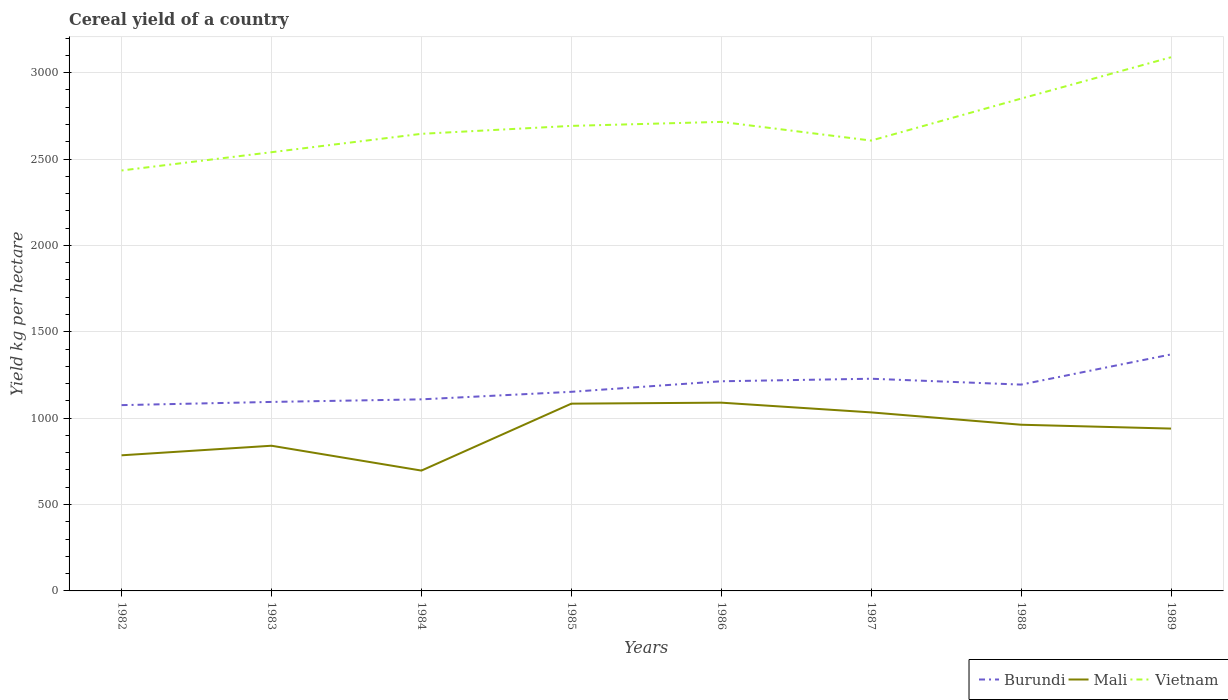Across all years, what is the maximum total cereal yield in Mali?
Your answer should be very brief. 696.56. In which year was the total cereal yield in Burundi maximum?
Provide a short and direct response. 1982. What is the total total cereal yield in Mali in the graph?
Make the answer very short. -154.73. What is the difference between the highest and the second highest total cereal yield in Mali?
Your answer should be compact. 393.21. Is the total cereal yield in Mali strictly greater than the total cereal yield in Vietnam over the years?
Make the answer very short. Yes. Are the values on the major ticks of Y-axis written in scientific E-notation?
Offer a terse response. No. Does the graph contain any zero values?
Your answer should be compact. No. Does the graph contain grids?
Provide a succinct answer. Yes. How are the legend labels stacked?
Offer a terse response. Horizontal. What is the title of the graph?
Offer a terse response. Cereal yield of a country. Does "Gambia, The" appear as one of the legend labels in the graph?
Make the answer very short. No. What is the label or title of the X-axis?
Make the answer very short. Years. What is the label or title of the Y-axis?
Provide a succinct answer. Yield kg per hectare. What is the Yield kg per hectare in Burundi in 1982?
Your answer should be compact. 1075.43. What is the Yield kg per hectare of Mali in 1982?
Offer a terse response. 785. What is the Yield kg per hectare in Vietnam in 1982?
Keep it short and to the point. 2433.62. What is the Yield kg per hectare of Burundi in 1983?
Offer a terse response. 1093.98. What is the Yield kg per hectare in Mali in 1983?
Your answer should be very brief. 840.42. What is the Yield kg per hectare in Vietnam in 1983?
Make the answer very short. 2539.45. What is the Yield kg per hectare in Burundi in 1984?
Make the answer very short. 1108.91. What is the Yield kg per hectare in Mali in 1984?
Your answer should be very brief. 696.56. What is the Yield kg per hectare of Vietnam in 1984?
Ensure brevity in your answer.  2645.85. What is the Yield kg per hectare in Burundi in 1985?
Ensure brevity in your answer.  1152.5. What is the Yield kg per hectare of Mali in 1985?
Your answer should be very brief. 1083.96. What is the Yield kg per hectare of Vietnam in 1985?
Make the answer very short. 2691.79. What is the Yield kg per hectare of Burundi in 1986?
Provide a succinct answer. 1213.53. What is the Yield kg per hectare in Mali in 1986?
Keep it short and to the point. 1089.77. What is the Yield kg per hectare in Vietnam in 1986?
Your response must be concise. 2715.06. What is the Yield kg per hectare of Burundi in 1987?
Make the answer very short. 1228.23. What is the Yield kg per hectare of Mali in 1987?
Offer a terse response. 1033.4. What is the Yield kg per hectare of Vietnam in 1987?
Provide a succinct answer. 2606.82. What is the Yield kg per hectare of Burundi in 1988?
Make the answer very short. 1194.27. What is the Yield kg per hectare of Mali in 1988?
Your answer should be compact. 961.96. What is the Yield kg per hectare of Vietnam in 1988?
Give a very brief answer. 2849.78. What is the Yield kg per hectare of Burundi in 1989?
Your answer should be compact. 1368.96. What is the Yield kg per hectare in Mali in 1989?
Give a very brief answer. 939.73. What is the Yield kg per hectare of Vietnam in 1989?
Give a very brief answer. 3089.15. Across all years, what is the maximum Yield kg per hectare of Burundi?
Your answer should be compact. 1368.96. Across all years, what is the maximum Yield kg per hectare in Mali?
Offer a terse response. 1089.77. Across all years, what is the maximum Yield kg per hectare of Vietnam?
Give a very brief answer. 3089.15. Across all years, what is the minimum Yield kg per hectare of Burundi?
Make the answer very short. 1075.43. Across all years, what is the minimum Yield kg per hectare in Mali?
Provide a short and direct response. 696.56. Across all years, what is the minimum Yield kg per hectare of Vietnam?
Make the answer very short. 2433.62. What is the total Yield kg per hectare of Burundi in the graph?
Your answer should be very brief. 9435.8. What is the total Yield kg per hectare of Mali in the graph?
Make the answer very short. 7430.8. What is the total Yield kg per hectare of Vietnam in the graph?
Your response must be concise. 2.16e+04. What is the difference between the Yield kg per hectare of Burundi in 1982 and that in 1983?
Your response must be concise. -18.55. What is the difference between the Yield kg per hectare of Mali in 1982 and that in 1983?
Give a very brief answer. -55.42. What is the difference between the Yield kg per hectare of Vietnam in 1982 and that in 1983?
Offer a very short reply. -105.83. What is the difference between the Yield kg per hectare in Burundi in 1982 and that in 1984?
Provide a short and direct response. -33.48. What is the difference between the Yield kg per hectare of Mali in 1982 and that in 1984?
Give a very brief answer. 88.44. What is the difference between the Yield kg per hectare of Vietnam in 1982 and that in 1984?
Ensure brevity in your answer.  -212.22. What is the difference between the Yield kg per hectare of Burundi in 1982 and that in 1985?
Provide a short and direct response. -77.07. What is the difference between the Yield kg per hectare in Mali in 1982 and that in 1985?
Your answer should be compact. -298.96. What is the difference between the Yield kg per hectare in Vietnam in 1982 and that in 1985?
Offer a terse response. -258.17. What is the difference between the Yield kg per hectare in Burundi in 1982 and that in 1986?
Offer a very short reply. -138.1. What is the difference between the Yield kg per hectare of Mali in 1982 and that in 1986?
Offer a terse response. -304.77. What is the difference between the Yield kg per hectare in Vietnam in 1982 and that in 1986?
Ensure brevity in your answer.  -281.43. What is the difference between the Yield kg per hectare in Burundi in 1982 and that in 1987?
Ensure brevity in your answer.  -152.81. What is the difference between the Yield kg per hectare of Mali in 1982 and that in 1987?
Ensure brevity in your answer.  -248.4. What is the difference between the Yield kg per hectare in Vietnam in 1982 and that in 1987?
Your answer should be very brief. -173.2. What is the difference between the Yield kg per hectare of Burundi in 1982 and that in 1988?
Offer a very short reply. -118.84. What is the difference between the Yield kg per hectare in Mali in 1982 and that in 1988?
Ensure brevity in your answer.  -176.96. What is the difference between the Yield kg per hectare of Vietnam in 1982 and that in 1988?
Offer a very short reply. -416.16. What is the difference between the Yield kg per hectare of Burundi in 1982 and that in 1989?
Offer a terse response. -293.53. What is the difference between the Yield kg per hectare of Mali in 1982 and that in 1989?
Your response must be concise. -154.73. What is the difference between the Yield kg per hectare of Vietnam in 1982 and that in 1989?
Offer a terse response. -655.53. What is the difference between the Yield kg per hectare in Burundi in 1983 and that in 1984?
Provide a short and direct response. -14.94. What is the difference between the Yield kg per hectare of Mali in 1983 and that in 1984?
Provide a short and direct response. 143.86. What is the difference between the Yield kg per hectare in Vietnam in 1983 and that in 1984?
Your answer should be very brief. -106.4. What is the difference between the Yield kg per hectare of Burundi in 1983 and that in 1985?
Keep it short and to the point. -58.52. What is the difference between the Yield kg per hectare in Mali in 1983 and that in 1985?
Give a very brief answer. -243.54. What is the difference between the Yield kg per hectare of Vietnam in 1983 and that in 1985?
Your answer should be compact. -152.34. What is the difference between the Yield kg per hectare of Burundi in 1983 and that in 1986?
Your answer should be very brief. -119.56. What is the difference between the Yield kg per hectare of Mali in 1983 and that in 1986?
Offer a terse response. -249.35. What is the difference between the Yield kg per hectare of Vietnam in 1983 and that in 1986?
Your answer should be very brief. -175.61. What is the difference between the Yield kg per hectare of Burundi in 1983 and that in 1987?
Your answer should be compact. -134.26. What is the difference between the Yield kg per hectare in Mali in 1983 and that in 1987?
Give a very brief answer. -192.98. What is the difference between the Yield kg per hectare in Vietnam in 1983 and that in 1987?
Your answer should be compact. -67.37. What is the difference between the Yield kg per hectare of Burundi in 1983 and that in 1988?
Keep it short and to the point. -100.29. What is the difference between the Yield kg per hectare of Mali in 1983 and that in 1988?
Keep it short and to the point. -121.54. What is the difference between the Yield kg per hectare in Vietnam in 1983 and that in 1988?
Ensure brevity in your answer.  -310.33. What is the difference between the Yield kg per hectare in Burundi in 1983 and that in 1989?
Your response must be concise. -274.98. What is the difference between the Yield kg per hectare of Mali in 1983 and that in 1989?
Give a very brief answer. -99.31. What is the difference between the Yield kg per hectare of Vietnam in 1983 and that in 1989?
Make the answer very short. -549.7. What is the difference between the Yield kg per hectare of Burundi in 1984 and that in 1985?
Offer a very short reply. -43.59. What is the difference between the Yield kg per hectare of Mali in 1984 and that in 1985?
Your answer should be very brief. -387.39. What is the difference between the Yield kg per hectare in Vietnam in 1984 and that in 1985?
Give a very brief answer. -45.94. What is the difference between the Yield kg per hectare of Burundi in 1984 and that in 1986?
Your answer should be very brief. -104.62. What is the difference between the Yield kg per hectare of Mali in 1984 and that in 1986?
Ensure brevity in your answer.  -393.21. What is the difference between the Yield kg per hectare of Vietnam in 1984 and that in 1986?
Your answer should be very brief. -69.21. What is the difference between the Yield kg per hectare in Burundi in 1984 and that in 1987?
Make the answer very short. -119.32. What is the difference between the Yield kg per hectare in Mali in 1984 and that in 1987?
Provide a succinct answer. -336.84. What is the difference between the Yield kg per hectare in Vietnam in 1984 and that in 1987?
Keep it short and to the point. 39.03. What is the difference between the Yield kg per hectare in Burundi in 1984 and that in 1988?
Offer a terse response. -85.36. What is the difference between the Yield kg per hectare in Mali in 1984 and that in 1988?
Your answer should be compact. -265.4. What is the difference between the Yield kg per hectare of Vietnam in 1984 and that in 1988?
Your response must be concise. -203.94. What is the difference between the Yield kg per hectare of Burundi in 1984 and that in 1989?
Your answer should be very brief. -260.05. What is the difference between the Yield kg per hectare of Mali in 1984 and that in 1989?
Provide a short and direct response. -243.16. What is the difference between the Yield kg per hectare of Vietnam in 1984 and that in 1989?
Ensure brevity in your answer.  -443.3. What is the difference between the Yield kg per hectare of Burundi in 1985 and that in 1986?
Your answer should be compact. -61.03. What is the difference between the Yield kg per hectare of Mali in 1985 and that in 1986?
Offer a terse response. -5.82. What is the difference between the Yield kg per hectare in Vietnam in 1985 and that in 1986?
Ensure brevity in your answer.  -23.27. What is the difference between the Yield kg per hectare of Burundi in 1985 and that in 1987?
Provide a short and direct response. -75.73. What is the difference between the Yield kg per hectare of Mali in 1985 and that in 1987?
Keep it short and to the point. 50.55. What is the difference between the Yield kg per hectare of Vietnam in 1985 and that in 1987?
Ensure brevity in your answer.  84.97. What is the difference between the Yield kg per hectare of Burundi in 1985 and that in 1988?
Offer a very short reply. -41.77. What is the difference between the Yield kg per hectare of Mali in 1985 and that in 1988?
Your response must be concise. 122. What is the difference between the Yield kg per hectare in Vietnam in 1985 and that in 1988?
Ensure brevity in your answer.  -158. What is the difference between the Yield kg per hectare of Burundi in 1985 and that in 1989?
Provide a succinct answer. -216.46. What is the difference between the Yield kg per hectare in Mali in 1985 and that in 1989?
Offer a terse response. 144.23. What is the difference between the Yield kg per hectare in Vietnam in 1985 and that in 1989?
Your answer should be compact. -397.36. What is the difference between the Yield kg per hectare in Burundi in 1986 and that in 1987?
Ensure brevity in your answer.  -14.7. What is the difference between the Yield kg per hectare of Mali in 1986 and that in 1987?
Provide a short and direct response. 56.37. What is the difference between the Yield kg per hectare in Vietnam in 1986 and that in 1987?
Provide a succinct answer. 108.24. What is the difference between the Yield kg per hectare in Burundi in 1986 and that in 1988?
Offer a very short reply. 19.26. What is the difference between the Yield kg per hectare in Mali in 1986 and that in 1988?
Provide a succinct answer. 127.81. What is the difference between the Yield kg per hectare in Vietnam in 1986 and that in 1988?
Give a very brief answer. -134.73. What is the difference between the Yield kg per hectare in Burundi in 1986 and that in 1989?
Provide a short and direct response. -155.43. What is the difference between the Yield kg per hectare of Mali in 1986 and that in 1989?
Your response must be concise. 150.05. What is the difference between the Yield kg per hectare in Vietnam in 1986 and that in 1989?
Make the answer very short. -374.1. What is the difference between the Yield kg per hectare in Burundi in 1987 and that in 1988?
Your answer should be very brief. 33.96. What is the difference between the Yield kg per hectare of Mali in 1987 and that in 1988?
Make the answer very short. 71.44. What is the difference between the Yield kg per hectare in Vietnam in 1987 and that in 1988?
Your answer should be compact. -242.96. What is the difference between the Yield kg per hectare of Burundi in 1987 and that in 1989?
Your answer should be compact. -140.72. What is the difference between the Yield kg per hectare of Mali in 1987 and that in 1989?
Provide a short and direct response. 93.68. What is the difference between the Yield kg per hectare in Vietnam in 1987 and that in 1989?
Offer a very short reply. -482.33. What is the difference between the Yield kg per hectare of Burundi in 1988 and that in 1989?
Your answer should be compact. -174.69. What is the difference between the Yield kg per hectare of Mali in 1988 and that in 1989?
Offer a very short reply. 22.23. What is the difference between the Yield kg per hectare in Vietnam in 1988 and that in 1989?
Offer a very short reply. -239.37. What is the difference between the Yield kg per hectare of Burundi in 1982 and the Yield kg per hectare of Mali in 1983?
Make the answer very short. 235. What is the difference between the Yield kg per hectare of Burundi in 1982 and the Yield kg per hectare of Vietnam in 1983?
Offer a terse response. -1464.02. What is the difference between the Yield kg per hectare in Mali in 1982 and the Yield kg per hectare in Vietnam in 1983?
Ensure brevity in your answer.  -1754.45. What is the difference between the Yield kg per hectare in Burundi in 1982 and the Yield kg per hectare in Mali in 1984?
Your answer should be very brief. 378.86. What is the difference between the Yield kg per hectare of Burundi in 1982 and the Yield kg per hectare of Vietnam in 1984?
Ensure brevity in your answer.  -1570.42. What is the difference between the Yield kg per hectare in Mali in 1982 and the Yield kg per hectare in Vietnam in 1984?
Keep it short and to the point. -1860.85. What is the difference between the Yield kg per hectare in Burundi in 1982 and the Yield kg per hectare in Mali in 1985?
Provide a short and direct response. -8.53. What is the difference between the Yield kg per hectare of Burundi in 1982 and the Yield kg per hectare of Vietnam in 1985?
Ensure brevity in your answer.  -1616.36. What is the difference between the Yield kg per hectare of Mali in 1982 and the Yield kg per hectare of Vietnam in 1985?
Offer a very short reply. -1906.79. What is the difference between the Yield kg per hectare in Burundi in 1982 and the Yield kg per hectare in Mali in 1986?
Ensure brevity in your answer.  -14.35. What is the difference between the Yield kg per hectare in Burundi in 1982 and the Yield kg per hectare in Vietnam in 1986?
Give a very brief answer. -1639.63. What is the difference between the Yield kg per hectare in Mali in 1982 and the Yield kg per hectare in Vietnam in 1986?
Your response must be concise. -1930.06. What is the difference between the Yield kg per hectare in Burundi in 1982 and the Yield kg per hectare in Mali in 1987?
Your answer should be very brief. 42.02. What is the difference between the Yield kg per hectare in Burundi in 1982 and the Yield kg per hectare in Vietnam in 1987?
Provide a succinct answer. -1531.39. What is the difference between the Yield kg per hectare of Mali in 1982 and the Yield kg per hectare of Vietnam in 1987?
Provide a succinct answer. -1821.82. What is the difference between the Yield kg per hectare of Burundi in 1982 and the Yield kg per hectare of Mali in 1988?
Your response must be concise. 113.47. What is the difference between the Yield kg per hectare of Burundi in 1982 and the Yield kg per hectare of Vietnam in 1988?
Offer a terse response. -1774.36. What is the difference between the Yield kg per hectare in Mali in 1982 and the Yield kg per hectare in Vietnam in 1988?
Your answer should be compact. -2064.78. What is the difference between the Yield kg per hectare of Burundi in 1982 and the Yield kg per hectare of Mali in 1989?
Offer a terse response. 135.7. What is the difference between the Yield kg per hectare of Burundi in 1982 and the Yield kg per hectare of Vietnam in 1989?
Your response must be concise. -2013.72. What is the difference between the Yield kg per hectare in Mali in 1982 and the Yield kg per hectare in Vietnam in 1989?
Ensure brevity in your answer.  -2304.15. What is the difference between the Yield kg per hectare in Burundi in 1983 and the Yield kg per hectare in Mali in 1984?
Offer a very short reply. 397.41. What is the difference between the Yield kg per hectare of Burundi in 1983 and the Yield kg per hectare of Vietnam in 1984?
Keep it short and to the point. -1551.87. What is the difference between the Yield kg per hectare of Mali in 1983 and the Yield kg per hectare of Vietnam in 1984?
Your response must be concise. -1805.43. What is the difference between the Yield kg per hectare in Burundi in 1983 and the Yield kg per hectare in Mali in 1985?
Provide a succinct answer. 10.02. What is the difference between the Yield kg per hectare of Burundi in 1983 and the Yield kg per hectare of Vietnam in 1985?
Your response must be concise. -1597.81. What is the difference between the Yield kg per hectare in Mali in 1983 and the Yield kg per hectare in Vietnam in 1985?
Give a very brief answer. -1851.37. What is the difference between the Yield kg per hectare of Burundi in 1983 and the Yield kg per hectare of Mali in 1986?
Provide a succinct answer. 4.2. What is the difference between the Yield kg per hectare in Burundi in 1983 and the Yield kg per hectare in Vietnam in 1986?
Keep it short and to the point. -1621.08. What is the difference between the Yield kg per hectare of Mali in 1983 and the Yield kg per hectare of Vietnam in 1986?
Your answer should be very brief. -1874.63. What is the difference between the Yield kg per hectare in Burundi in 1983 and the Yield kg per hectare in Mali in 1987?
Your answer should be compact. 60.57. What is the difference between the Yield kg per hectare in Burundi in 1983 and the Yield kg per hectare in Vietnam in 1987?
Ensure brevity in your answer.  -1512.84. What is the difference between the Yield kg per hectare of Mali in 1983 and the Yield kg per hectare of Vietnam in 1987?
Provide a succinct answer. -1766.4. What is the difference between the Yield kg per hectare of Burundi in 1983 and the Yield kg per hectare of Mali in 1988?
Provide a short and direct response. 132.02. What is the difference between the Yield kg per hectare in Burundi in 1983 and the Yield kg per hectare in Vietnam in 1988?
Your response must be concise. -1755.81. What is the difference between the Yield kg per hectare in Mali in 1983 and the Yield kg per hectare in Vietnam in 1988?
Give a very brief answer. -2009.36. What is the difference between the Yield kg per hectare in Burundi in 1983 and the Yield kg per hectare in Mali in 1989?
Your answer should be compact. 154.25. What is the difference between the Yield kg per hectare in Burundi in 1983 and the Yield kg per hectare in Vietnam in 1989?
Give a very brief answer. -1995.17. What is the difference between the Yield kg per hectare in Mali in 1983 and the Yield kg per hectare in Vietnam in 1989?
Offer a terse response. -2248.73. What is the difference between the Yield kg per hectare in Burundi in 1984 and the Yield kg per hectare in Mali in 1985?
Provide a short and direct response. 24.95. What is the difference between the Yield kg per hectare of Burundi in 1984 and the Yield kg per hectare of Vietnam in 1985?
Your response must be concise. -1582.88. What is the difference between the Yield kg per hectare of Mali in 1984 and the Yield kg per hectare of Vietnam in 1985?
Provide a succinct answer. -1995.23. What is the difference between the Yield kg per hectare in Burundi in 1984 and the Yield kg per hectare in Mali in 1986?
Offer a very short reply. 19.14. What is the difference between the Yield kg per hectare of Burundi in 1984 and the Yield kg per hectare of Vietnam in 1986?
Your response must be concise. -1606.14. What is the difference between the Yield kg per hectare of Mali in 1984 and the Yield kg per hectare of Vietnam in 1986?
Your response must be concise. -2018.49. What is the difference between the Yield kg per hectare in Burundi in 1984 and the Yield kg per hectare in Mali in 1987?
Give a very brief answer. 75.51. What is the difference between the Yield kg per hectare in Burundi in 1984 and the Yield kg per hectare in Vietnam in 1987?
Offer a very short reply. -1497.91. What is the difference between the Yield kg per hectare of Mali in 1984 and the Yield kg per hectare of Vietnam in 1987?
Your answer should be very brief. -1910.26. What is the difference between the Yield kg per hectare in Burundi in 1984 and the Yield kg per hectare in Mali in 1988?
Keep it short and to the point. 146.95. What is the difference between the Yield kg per hectare of Burundi in 1984 and the Yield kg per hectare of Vietnam in 1988?
Give a very brief answer. -1740.87. What is the difference between the Yield kg per hectare in Mali in 1984 and the Yield kg per hectare in Vietnam in 1988?
Give a very brief answer. -2153.22. What is the difference between the Yield kg per hectare of Burundi in 1984 and the Yield kg per hectare of Mali in 1989?
Your response must be concise. 169.18. What is the difference between the Yield kg per hectare in Burundi in 1984 and the Yield kg per hectare in Vietnam in 1989?
Your answer should be compact. -1980.24. What is the difference between the Yield kg per hectare of Mali in 1984 and the Yield kg per hectare of Vietnam in 1989?
Provide a succinct answer. -2392.59. What is the difference between the Yield kg per hectare of Burundi in 1985 and the Yield kg per hectare of Mali in 1986?
Make the answer very short. 62.73. What is the difference between the Yield kg per hectare of Burundi in 1985 and the Yield kg per hectare of Vietnam in 1986?
Offer a terse response. -1562.56. What is the difference between the Yield kg per hectare in Mali in 1985 and the Yield kg per hectare in Vietnam in 1986?
Keep it short and to the point. -1631.1. What is the difference between the Yield kg per hectare of Burundi in 1985 and the Yield kg per hectare of Mali in 1987?
Give a very brief answer. 119.1. What is the difference between the Yield kg per hectare in Burundi in 1985 and the Yield kg per hectare in Vietnam in 1987?
Ensure brevity in your answer.  -1454.32. What is the difference between the Yield kg per hectare in Mali in 1985 and the Yield kg per hectare in Vietnam in 1987?
Your answer should be compact. -1522.86. What is the difference between the Yield kg per hectare of Burundi in 1985 and the Yield kg per hectare of Mali in 1988?
Provide a short and direct response. 190.54. What is the difference between the Yield kg per hectare in Burundi in 1985 and the Yield kg per hectare in Vietnam in 1988?
Give a very brief answer. -1697.28. What is the difference between the Yield kg per hectare of Mali in 1985 and the Yield kg per hectare of Vietnam in 1988?
Provide a short and direct response. -1765.83. What is the difference between the Yield kg per hectare in Burundi in 1985 and the Yield kg per hectare in Mali in 1989?
Offer a very short reply. 212.77. What is the difference between the Yield kg per hectare of Burundi in 1985 and the Yield kg per hectare of Vietnam in 1989?
Give a very brief answer. -1936.65. What is the difference between the Yield kg per hectare in Mali in 1985 and the Yield kg per hectare in Vietnam in 1989?
Your answer should be compact. -2005.19. What is the difference between the Yield kg per hectare of Burundi in 1986 and the Yield kg per hectare of Mali in 1987?
Provide a short and direct response. 180.13. What is the difference between the Yield kg per hectare in Burundi in 1986 and the Yield kg per hectare in Vietnam in 1987?
Give a very brief answer. -1393.29. What is the difference between the Yield kg per hectare of Mali in 1986 and the Yield kg per hectare of Vietnam in 1987?
Offer a terse response. -1517.05. What is the difference between the Yield kg per hectare of Burundi in 1986 and the Yield kg per hectare of Mali in 1988?
Make the answer very short. 251.57. What is the difference between the Yield kg per hectare of Burundi in 1986 and the Yield kg per hectare of Vietnam in 1988?
Ensure brevity in your answer.  -1636.25. What is the difference between the Yield kg per hectare of Mali in 1986 and the Yield kg per hectare of Vietnam in 1988?
Ensure brevity in your answer.  -1760.01. What is the difference between the Yield kg per hectare of Burundi in 1986 and the Yield kg per hectare of Mali in 1989?
Give a very brief answer. 273.8. What is the difference between the Yield kg per hectare of Burundi in 1986 and the Yield kg per hectare of Vietnam in 1989?
Provide a short and direct response. -1875.62. What is the difference between the Yield kg per hectare in Mali in 1986 and the Yield kg per hectare in Vietnam in 1989?
Ensure brevity in your answer.  -1999.38. What is the difference between the Yield kg per hectare of Burundi in 1987 and the Yield kg per hectare of Mali in 1988?
Provide a short and direct response. 266.27. What is the difference between the Yield kg per hectare of Burundi in 1987 and the Yield kg per hectare of Vietnam in 1988?
Provide a short and direct response. -1621.55. What is the difference between the Yield kg per hectare of Mali in 1987 and the Yield kg per hectare of Vietnam in 1988?
Offer a terse response. -1816.38. What is the difference between the Yield kg per hectare in Burundi in 1987 and the Yield kg per hectare in Mali in 1989?
Make the answer very short. 288.5. What is the difference between the Yield kg per hectare of Burundi in 1987 and the Yield kg per hectare of Vietnam in 1989?
Your answer should be very brief. -1860.92. What is the difference between the Yield kg per hectare in Mali in 1987 and the Yield kg per hectare in Vietnam in 1989?
Your answer should be very brief. -2055.75. What is the difference between the Yield kg per hectare of Burundi in 1988 and the Yield kg per hectare of Mali in 1989?
Offer a very short reply. 254.54. What is the difference between the Yield kg per hectare of Burundi in 1988 and the Yield kg per hectare of Vietnam in 1989?
Ensure brevity in your answer.  -1894.88. What is the difference between the Yield kg per hectare of Mali in 1988 and the Yield kg per hectare of Vietnam in 1989?
Give a very brief answer. -2127.19. What is the average Yield kg per hectare of Burundi per year?
Your answer should be compact. 1179.47. What is the average Yield kg per hectare of Mali per year?
Keep it short and to the point. 928.85. What is the average Yield kg per hectare in Vietnam per year?
Keep it short and to the point. 2696.44. In the year 1982, what is the difference between the Yield kg per hectare in Burundi and Yield kg per hectare in Mali?
Make the answer very short. 290.43. In the year 1982, what is the difference between the Yield kg per hectare of Burundi and Yield kg per hectare of Vietnam?
Give a very brief answer. -1358.2. In the year 1982, what is the difference between the Yield kg per hectare of Mali and Yield kg per hectare of Vietnam?
Your response must be concise. -1648.62. In the year 1983, what is the difference between the Yield kg per hectare in Burundi and Yield kg per hectare in Mali?
Provide a succinct answer. 253.56. In the year 1983, what is the difference between the Yield kg per hectare of Burundi and Yield kg per hectare of Vietnam?
Your answer should be compact. -1445.47. In the year 1983, what is the difference between the Yield kg per hectare of Mali and Yield kg per hectare of Vietnam?
Your answer should be very brief. -1699.03. In the year 1984, what is the difference between the Yield kg per hectare in Burundi and Yield kg per hectare in Mali?
Your response must be concise. 412.35. In the year 1984, what is the difference between the Yield kg per hectare in Burundi and Yield kg per hectare in Vietnam?
Keep it short and to the point. -1536.94. In the year 1984, what is the difference between the Yield kg per hectare in Mali and Yield kg per hectare in Vietnam?
Your answer should be compact. -1949.29. In the year 1985, what is the difference between the Yield kg per hectare in Burundi and Yield kg per hectare in Mali?
Keep it short and to the point. 68.54. In the year 1985, what is the difference between the Yield kg per hectare in Burundi and Yield kg per hectare in Vietnam?
Keep it short and to the point. -1539.29. In the year 1985, what is the difference between the Yield kg per hectare of Mali and Yield kg per hectare of Vietnam?
Make the answer very short. -1607.83. In the year 1986, what is the difference between the Yield kg per hectare of Burundi and Yield kg per hectare of Mali?
Offer a very short reply. 123.76. In the year 1986, what is the difference between the Yield kg per hectare of Burundi and Yield kg per hectare of Vietnam?
Make the answer very short. -1501.53. In the year 1986, what is the difference between the Yield kg per hectare of Mali and Yield kg per hectare of Vietnam?
Provide a succinct answer. -1625.28. In the year 1987, what is the difference between the Yield kg per hectare in Burundi and Yield kg per hectare in Mali?
Your answer should be very brief. 194.83. In the year 1987, what is the difference between the Yield kg per hectare of Burundi and Yield kg per hectare of Vietnam?
Keep it short and to the point. -1378.59. In the year 1987, what is the difference between the Yield kg per hectare of Mali and Yield kg per hectare of Vietnam?
Your answer should be very brief. -1573.42. In the year 1988, what is the difference between the Yield kg per hectare of Burundi and Yield kg per hectare of Mali?
Give a very brief answer. 232.31. In the year 1988, what is the difference between the Yield kg per hectare of Burundi and Yield kg per hectare of Vietnam?
Your answer should be very brief. -1655.52. In the year 1988, what is the difference between the Yield kg per hectare of Mali and Yield kg per hectare of Vietnam?
Make the answer very short. -1887.82. In the year 1989, what is the difference between the Yield kg per hectare in Burundi and Yield kg per hectare in Mali?
Provide a succinct answer. 429.23. In the year 1989, what is the difference between the Yield kg per hectare of Burundi and Yield kg per hectare of Vietnam?
Give a very brief answer. -1720.19. In the year 1989, what is the difference between the Yield kg per hectare of Mali and Yield kg per hectare of Vietnam?
Your response must be concise. -2149.42. What is the ratio of the Yield kg per hectare of Burundi in 1982 to that in 1983?
Provide a short and direct response. 0.98. What is the ratio of the Yield kg per hectare of Mali in 1982 to that in 1983?
Your response must be concise. 0.93. What is the ratio of the Yield kg per hectare of Vietnam in 1982 to that in 1983?
Keep it short and to the point. 0.96. What is the ratio of the Yield kg per hectare in Burundi in 1982 to that in 1984?
Keep it short and to the point. 0.97. What is the ratio of the Yield kg per hectare of Mali in 1982 to that in 1984?
Give a very brief answer. 1.13. What is the ratio of the Yield kg per hectare in Vietnam in 1982 to that in 1984?
Offer a terse response. 0.92. What is the ratio of the Yield kg per hectare of Burundi in 1982 to that in 1985?
Give a very brief answer. 0.93. What is the ratio of the Yield kg per hectare in Mali in 1982 to that in 1985?
Provide a succinct answer. 0.72. What is the ratio of the Yield kg per hectare in Vietnam in 1982 to that in 1985?
Give a very brief answer. 0.9. What is the ratio of the Yield kg per hectare of Burundi in 1982 to that in 1986?
Your answer should be very brief. 0.89. What is the ratio of the Yield kg per hectare of Mali in 1982 to that in 1986?
Give a very brief answer. 0.72. What is the ratio of the Yield kg per hectare in Vietnam in 1982 to that in 1986?
Provide a succinct answer. 0.9. What is the ratio of the Yield kg per hectare in Burundi in 1982 to that in 1987?
Provide a short and direct response. 0.88. What is the ratio of the Yield kg per hectare of Mali in 1982 to that in 1987?
Make the answer very short. 0.76. What is the ratio of the Yield kg per hectare of Vietnam in 1982 to that in 1987?
Offer a terse response. 0.93. What is the ratio of the Yield kg per hectare in Burundi in 1982 to that in 1988?
Provide a short and direct response. 0.9. What is the ratio of the Yield kg per hectare in Mali in 1982 to that in 1988?
Offer a very short reply. 0.82. What is the ratio of the Yield kg per hectare in Vietnam in 1982 to that in 1988?
Your response must be concise. 0.85. What is the ratio of the Yield kg per hectare of Burundi in 1982 to that in 1989?
Your response must be concise. 0.79. What is the ratio of the Yield kg per hectare of Mali in 1982 to that in 1989?
Ensure brevity in your answer.  0.84. What is the ratio of the Yield kg per hectare of Vietnam in 1982 to that in 1989?
Keep it short and to the point. 0.79. What is the ratio of the Yield kg per hectare in Burundi in 1983 to that in 1984?
Give a very brief answer. 0.99. What is the ratio of the Yield kg per hectare of Mali in 1983 to that in 1984?
Your response must be concise. 1.21. What is the ratio of the Yield kg per hectare of Vietnam in 1983 to that in 1984?
Your answer should be very brief. 0.96. What is the ratio of the Yield kg per hectare of Burundi in 1983 to that in 1985?
Give a very brief answer. 0.95. What is the ratio of the Yield kg per hectare of Mali in 1983 to that in 1985?
Your answer should be very brief. 0.78. What is the ratio of the Yield kg per hectare in Vietnam in 1983 to that in 1985?
Keep it short and to the point. 0.94. What is the ratio of the Yield kg per hectare in Burundi in 1983 to that in 1986?
Make the answer very short. 0.9. What is the ratio of the Yield kg per hectare of Mali in 1983 to that in 1986?
Make the answer very short. 0.77. What is the ratio of the Yield kg per hectare in Vietnam in 1983 to that in 1986?
Your answer should be compact. 0.94. What is the ratio of the Yield kg per hectare of Burundi in 1983 to that in 1987?
Keep it short and to the point. 0.89. What is the ratio of the Yield kg per hectare in Mali in 1983 to that in 1987?
Ensure brevity in your answer.  0.81. What is the ratio of the Yield kg per hectare in Vietnam in 1983 to that in 1987?
Give a very brief answer. 0.97. What is the ratio of the Yield kg per hectare in Burundi in 1983 to that in 1988?
Ensure brevity in your answer.  0.92. What is the ratio of the Yield kg per hectare of Mali in 1983 to that in 1988?
Offer a very short reply. 0.87. What is the ratio of the Yield kg per hectare in Vietnam in 1983 to that in 1988?
Make the answer very short. 0.89. What is the ratio of the Yield kg per hectare of Burundi in 1983 to that in 1989?
Give a very brief answer. 0.8. What is the ratio of the Yield kg per hectare in Mali in 1983 to that in 1989?
Provide a short and direct response. 0.89. What is the ratio of the Yield kg per hectare in Vietnam in 1983 to that in 1989?
Give a very brief answer. 0.82. What is the ratio of the Yield kg per hectare in Burundi in 1984 to that in 1985?
Offer a terse response. 0.96. What is the ratio of the Yield kg per hectare of Mali in 1984 to that in 1985?
Offer a very short reply. 0.64. What is the ratio of the Yield kg per hectare of Vietnam in 1984 to that in 1985?
Provide a succinct answer. 0.98. What is the ratio of the Yield kg per hectare of Burundi in 1984 to that in 1986?
Offer a terse response. 0.91. What is the ratio of the Yield kg per hectare of Mali in 1984 to that in 1986?
Your answer should be very brief. 0.64. What is the ratio of the Yield kg per hectare of Vietnam in 1984 to that in 1986?
Provide a succinct answer. 0.97. What is the ratio of the Yield kg per hectare of Burundi in 1984 to that in 1987?
Your response must be concise. 0.9. What is the ratio of the Yield kg per hectare in Mali in 1984 to that in 1987?
Your answer should be very brief. 0.67. What is the ratio of the Yield kg per hectare in Vietnam in 1984 to that in 1987?
Your response must be concise. 1.01. What is the ratio of the Yield kg per hectare of Burundi in 1984 to that in 1988?
Give a very brief answer. 0.93. What is the ratio of the Yield kg per hectare of Mali in 1984 to that in 1988?
Offer a very short reply. 0.72. What is the ratio of the Yield kg per hectare in Vietnam in 1984 to that in 1988?
Your response must be concise. 0.93. What is the ratio of the Yield kg per hectare of Burundi in 1984 to that in 1989?
Provide a succinct answer. 0.81. What is the ratio of the Yield kg per hectare in Mali in 1984 to that in 1989?
Your answer should be compact. 0.74. What is the ratio of the Yield kg per hectare of Vietnam in 1984 to that in 1989?
Keep it short and to the point. 0.86. What is the ratio of the Yield kg per hectare in Burundi in 1985 to that in 1986?
Your response must be concise. 0.95. What is the ratio of the Yield kg per hectare of Vietnam in 1985 to that in 1986?
Ensure brevity in your answer.  0.99. What is the ratio of the Yield kg per hectare of Burundi in 1985 to that in 1987?
Offer a very short reply. 0.94. What is the ratio of the Yield kg per hectare of Mali in 1985 to that in 1987?
Provide a short and direct response. 1.05. What is the ratio of the Yield kg per hectare of Vietnam in 1985 to that in 1987?
Offer a very short reply. 1.03. What is the ratio of the Yield kg per hectare in Mali in 1985 to that in 1988?
Provide a succinct answer. 1.13. What is the ratio of the Yield kg per hectare of Vietnam in 1985 to that in 1988?
Give a very brief answer. 0.94. What is the ratio of the Yield kg per hectare in Burundi in 1985 to that in 1989?
Offer a very short reply. 0.84. What is the ratio of the Yield kg per hectare in Mali in 1985 to that in 1989?
Your answer should be compact. 1.15. What is the ratio of the Yield kg per hectare of Vietnam in 1985 to that in 1989?
Offer a terse response. 0.87. What is the ratio of the Yield kg per hectare of Mali in 1986 to that in 1987?
Your answer should be compact. 1.05. What is the ratio of the Yield kg per hectare in Vietnam in 1986 to that in 1987?
Provide a short and direct response. 1.04. What is the ratio of the Yield kg per hectare in Burundi in 1986 to that in 1988?
Ensure brevity in your answer.  1.02. What is the ratio of the Yield kg per hectare of Mali in 1986 to that in 1988?
Ensure brevity in your answer.  1.13. What is the ratio of the Yield kg per hectare of Vietnam in 1986 to that in 1988?
Ensure brevity in your answer.  0.95. What is the ratio of the Yield kg per hectare of Burundi in 1986 to that in 1989?
Give a very brief answer. 0.89. What is the ratio of the Yield kg per hectare of Mali in 1986 to that in 1989?
Make the answer very short. 1.16. What is the ratio of the Yield kg per hectare in Vietnam in 1986 to that in 1989?
Your answer should be very brief. 0.88. What is the ratio of the Yield kg per hectare of Burundi in 1987 to that in 1988?
Give a very brief answer. 1.03. What is the ratio of the Yield kg per hectare of Mali in 1987 to that in 1988?
Provide a succinct answer. 1.07. What is the ratio of the Yield kg per hectare in Vietnam in 1987 to that in 1988?
Provide a short and direct response. 0.91. What is the ratio of the Yield kg per hectare in Burundi in 1987 to that in 1989?
Keep it short and to the point. 0.9. What is the ratio of the Yield kg per hectare of Mali in 1987 to that in 1989?
Your response must be concise. 1.1. What is the ratio of the Yield kg per hectare of Vietnam in 1987 to that in 1989?
Offer a terse response. 0.84. What is the ratio of the Yield kg per hectare of Burundi in 1988 to that in 1989?
Ensure brevity in your answer.  0.87. What is the ratio of the Yield kg per hectare of Mali in 1988 to that in 1989?
Offer a very short reply. 1.02. What is the ratio of the Yield kg per hectare of Vietnam in 1988 to that in 1989?
Your answer should be compact. 0.92. What is the difference between the highest and the second highest Yield kg per hectare in Burundi?
Offer a terse response. 140.72. What is the difference between the highest and the second highest Yield kg per hectare in Mali?
Your answer should be very brief. 5.82. What is the difference between the highest and the second highest Yield kg per hectare of Vietnam?
Keep it short and to the point. 239.37. What is the difference between the highest and the lowest Yield kg per hectare in Burundi?
Ensure brevity in your answer.  293.53. What is the difference between the highest and the lowest Yield kg per hectare in Mali?
Provide a short and direct response. 393.21. What is the difference between the highest and the lowest Yield kg per hectare of Vietnam?
Your answer should be compact. 655.53. 